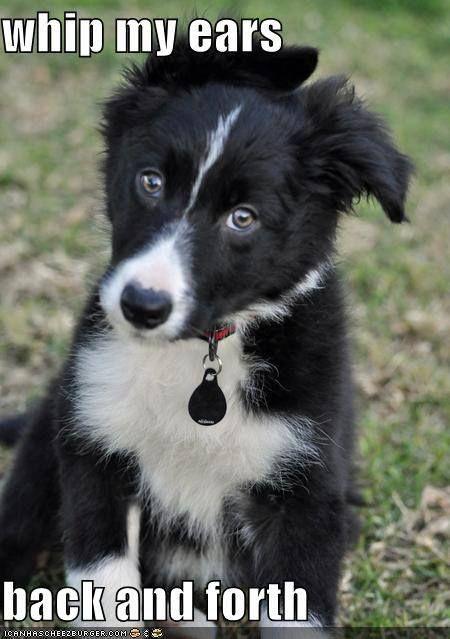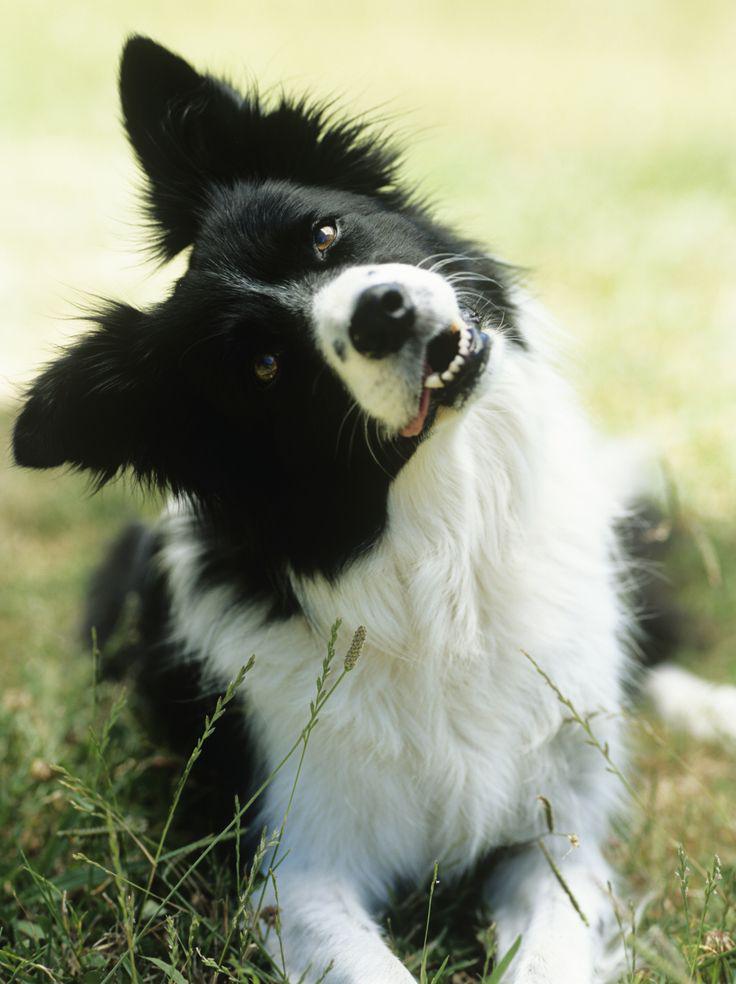The first image is the image on the left, the second image is the image on the right. Analyze the images presented: Is the assertion "An image shows a dog reclining on the grass with its head cocked at a sharp angle." valid? Answer yes or no. Yes. The first image is the image on the left, the second image is the image on the right. Examine the images to the left and right. Is the description "The dog in one of the images has its head tilted to the side." accurate? Answer yes or no. Yes. 